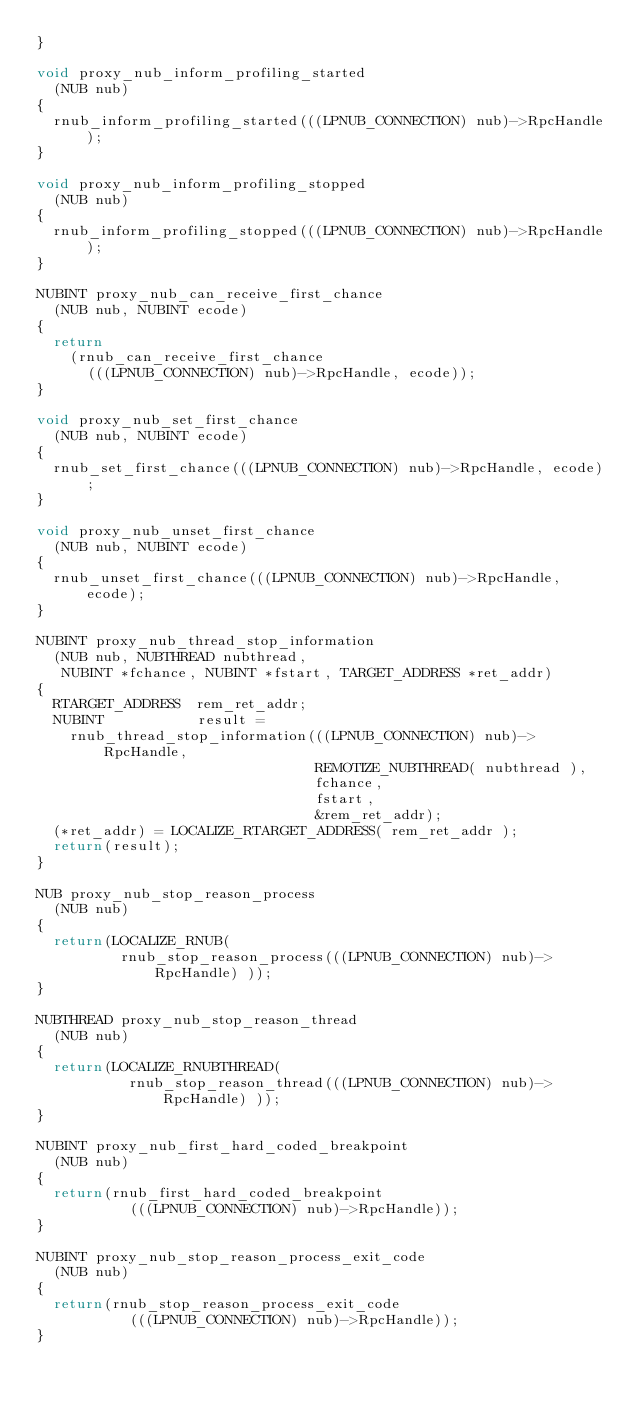Convert code to text. <code><loc_0><loc_0><loc_500><loc_500><_C_>}

void proxy_nub_inform_profiling_started
  (NUB nub)
{
  rnub_inform_profiling_started(((LPNUB_CONNECTION) nub)->RpcHandle);
}

void proxy_nub_inform_profiling_stopped
  (NUB nub)
{
  rnub_inform_profiling_stopped(((LPNUB_CONNECTION) nub)->RpcHandle);
}

NUBINT proxy_nub_can_receive_first_chance
  (NUB nub, NUBINT ecode)
{
  return
    (rnub_can_receive_first_chance
      (((LPNUB_CONNECTION) nub)->RpcHandle, ecode));
}

void proxy_nub_set_first_chance
  (NUB nub, NUBINT ecode)
{
  rnub_set_first_chance(((LPNUB_CONNECTION) nub)->RpcHandle, ecode);
}

void proxy_nub_unset_first_chance
  (NUB nub, NUBINT ecode)
{
  rnub_unset_first_chance(((LPNUB_CONNECTION) nub)->RpcHandle, ecode);
}

NUBINT proxy_nub_thread_stop_information
  (NUB nub, NUBTHREAD nubthread,
   NUBINT *fchance, NUBINT *fstart, TARGET_ADDRESS *ret_addr)
{
  RTARGET_ADDRESS  rem_ret_addr;
  NUBINT           result =
    rnub_thread_stop_information(((LPNUB_CONNECTION) nub)->RpcHandle,
                                 REMOTIZE_NUBTHREAD( nubthread ),
                                 fchance,
                                 fstart,
                                 &rem_ret_addr);
  (*ret_addr) = LOCALIZE_RTARGET_ADDRESS( rem_ret_addr );
  return(result);
}

NUB proxy_nub_stop_reason_process
  (NUB nub)
{
  return(LOCALIZE_RNUB( 
          rnub_stop_reason_process(((LPNUB_CONNECTION) nub)->RpcHandle) ));
}

NUBTHREAD proxy_nub_stop_reason_thread
  (NUB nub)
{
  return(LOCALIZE_RNUBTHREAD( 
           rnub_stop_reason_thread(((LPNUB_CONNECTION) nub)->RpcHandle) ));
}

NUBINT proxy_nub_first_hard_coded_breakpoint
  (NUB nub)
{
  return(rnub_first_hard_coded_breakpoint
           (((LPNUB_CONNECTION) nub)->RpcHandle));
}

NUBINT proxy_nub_stop_reason_process_exit_code
  (NUB nub)
{
  return(rnub_stop_reason_process_exit_code
           (((LPNUB_CONNECTION) nub)->RpcHandle));
}
</code> 